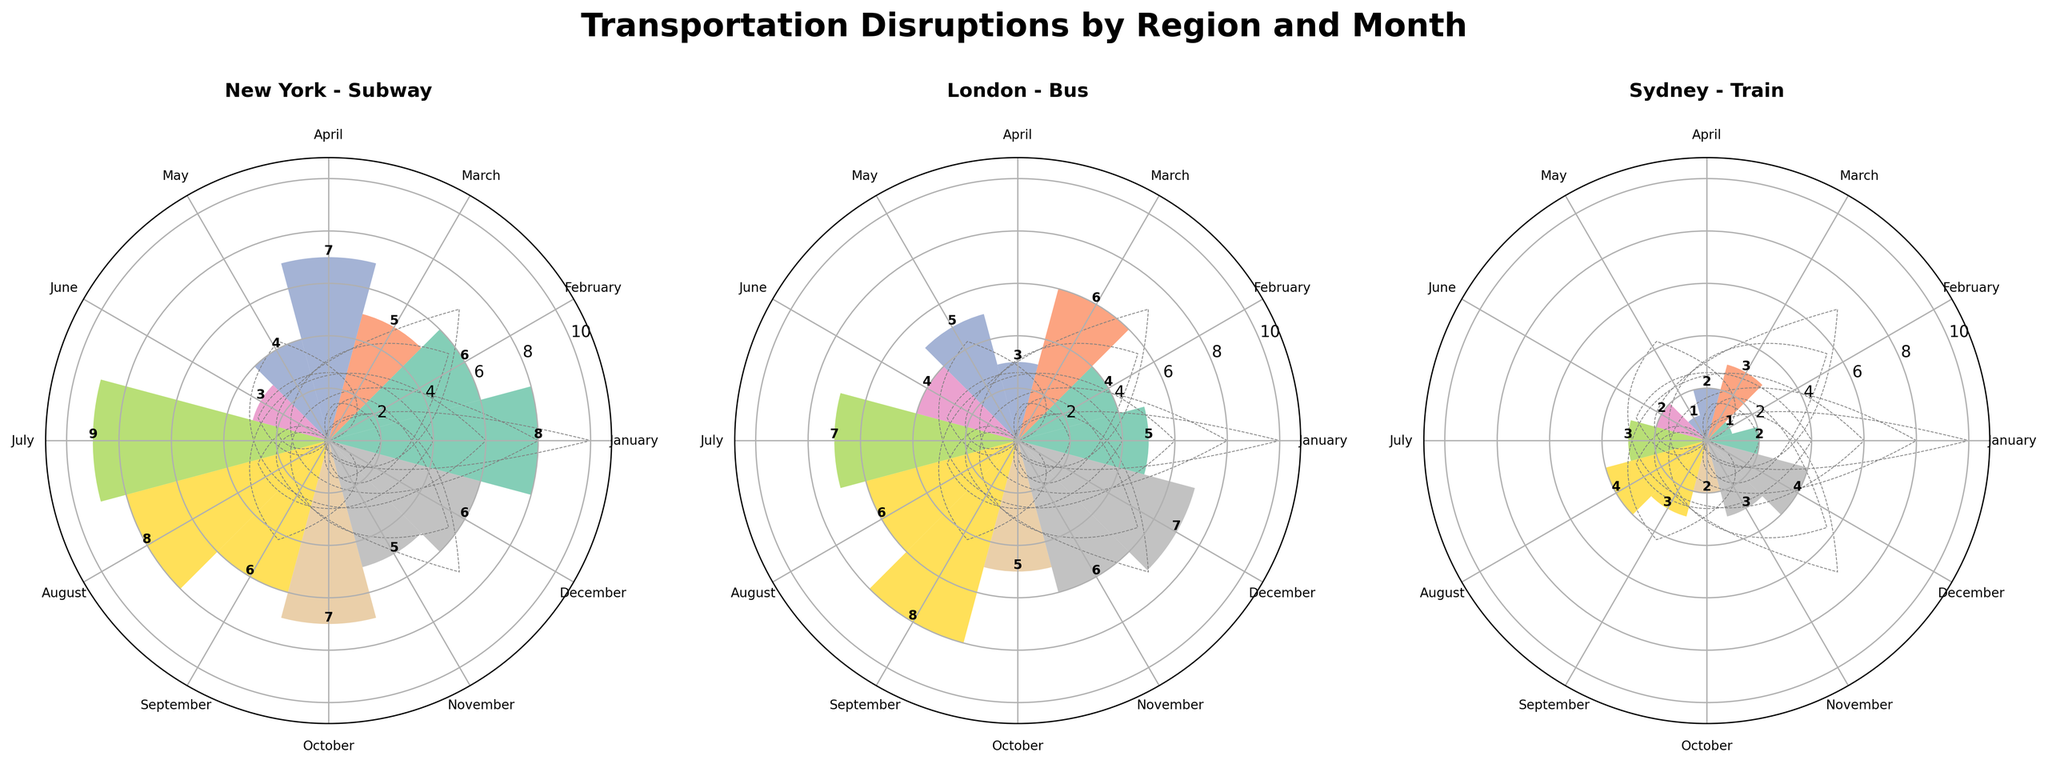What is the title of the figure? The title of the figure is located at the top center and reads, 'Transportation Disruptions by Region and Month'.
Answer: Transportation Disruptions by Region and Month What regions are represented in the figure? The regions represented are part of the subplot titles with three subplots denoted as 'New York - Subway', 'London - Bus', and 'Sydney - Train'.
Answer: New York, London, Sydney Which month shows the highest incidence rate in New York? In the subplot for New York, the largest bar can be identified visually. It corresponds to July with a height of 9.
Answer: July What's the average Incidence Rate for Sydney across all months? Calculate the average using the incidence rates: (2+1+3+2+1+2+3+4+3+2+3+4)/12. This sum is 32, and dividing by 12 gives 32/12.
Answer: 2.67 In which months does London have more disruptions than Sydney? Compare the bar heights for London vs. Sydney for each month. London has higher bars than Sydney in January, March, May, September, November, and December.
Answer: January, March, May, September, November, December How many months have the same incidence rate for all three regions? Visually inspect and count the months where all three bars reach identical heights. For example, in June, all regions have two incidences.
Answer: One (June) Which region has the highest average monthly incidence rate? Calculate the average for each region by summing the incidences and dividing by 12. Compare the averages: New York (70/12 = 5.83), London (66/12 = 5.5), Sydney (32/12 = 2.67).
Answer: New York Does July have a higher incidence rate in New York or London? Compare the height of the bars for July in both subplots. New York's bar is at 9, while London's is at 7.
Answer: New York Which month shows the lowest incidence rate for Sydney? Identify the shortest bar in the Sydney subplot, which occurs in February and May, both with a height of 1.
Answer: February, May 